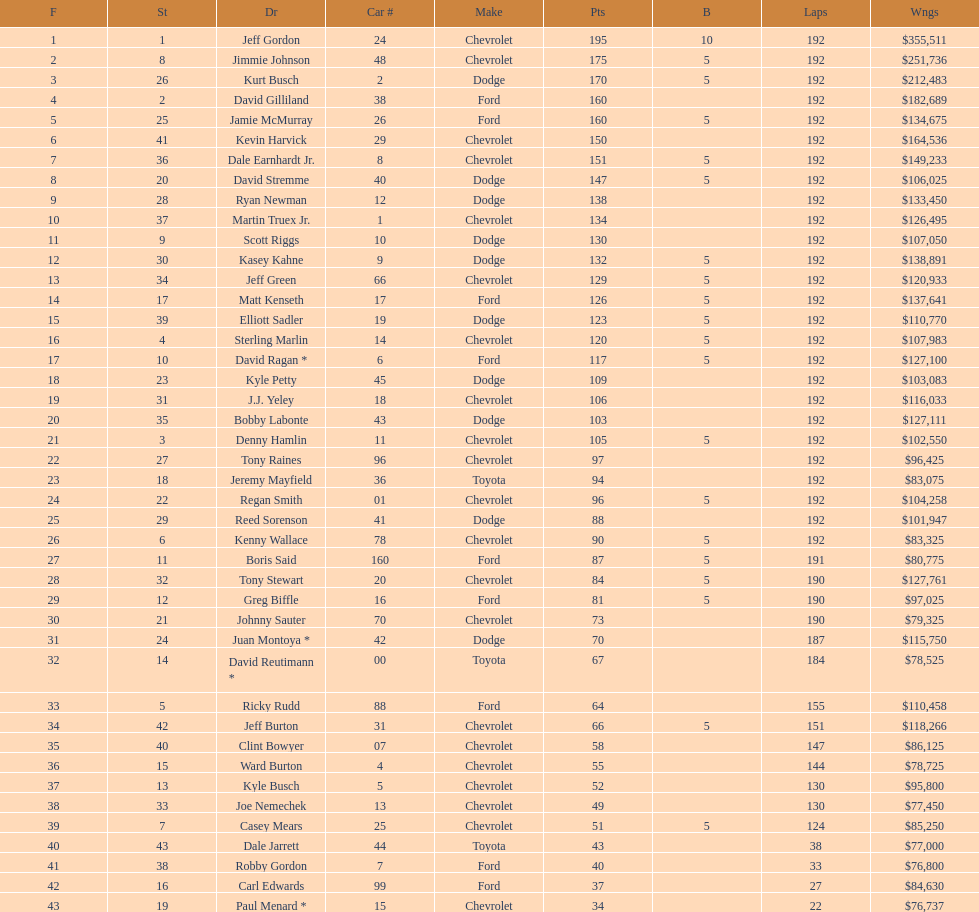How many race car drivers out of the 43 listed drove toyotas? 3. 